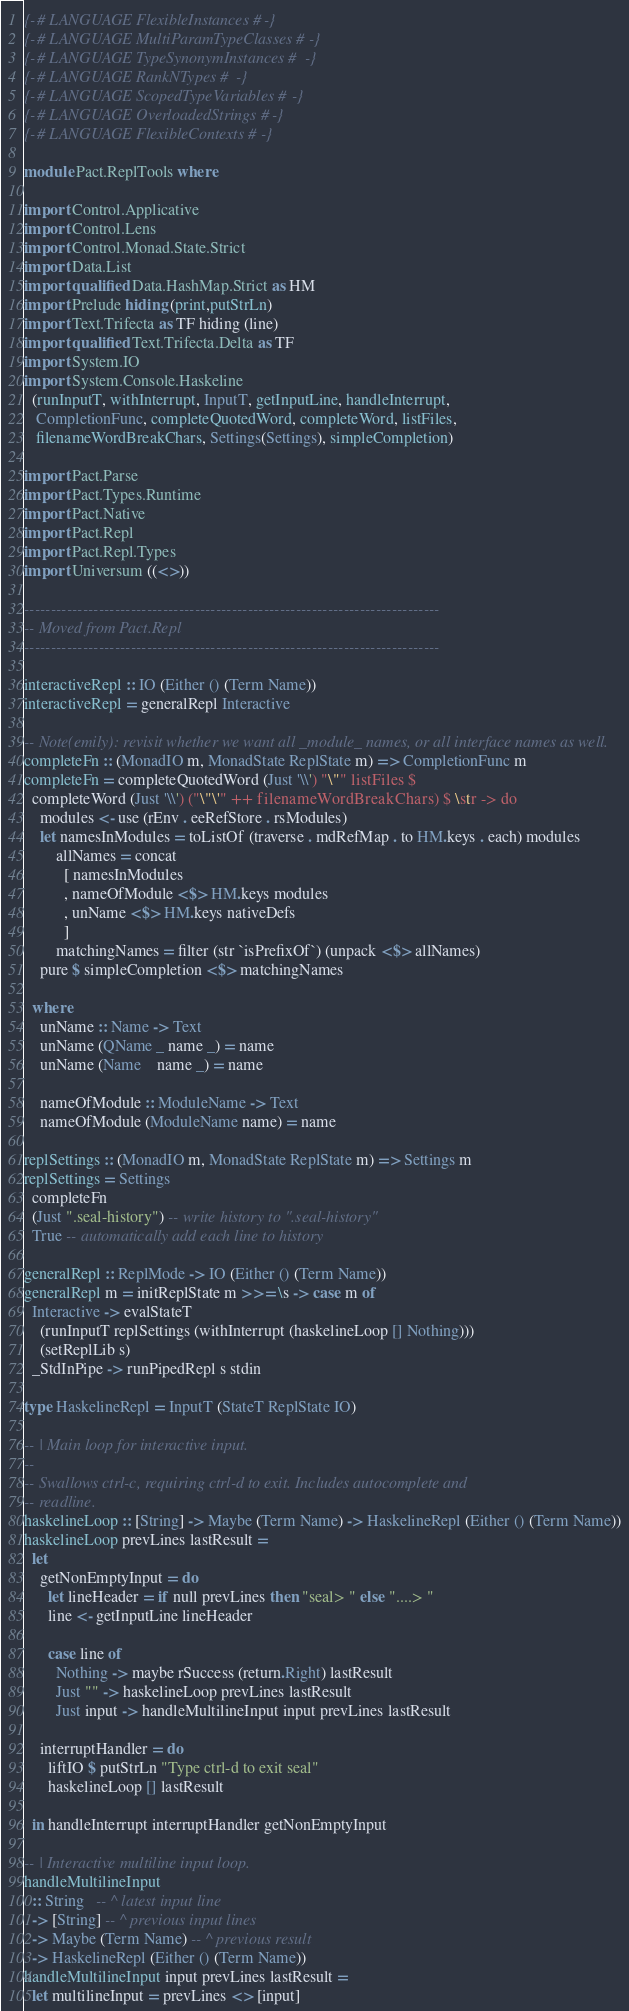Convert code to text. <code><loc_0><loc_0><loc_500><loc_500><_Haskell_>{-# LANGUAGE FlexibleInstances #-}
{-# LANGUAGE MultiParamTypeClasses #-}
{-# LANGUAGE TypeSynonymInstances #-}
{-# LANGUAGE RankNTypes #-}
{-# LANGUAGE ScopedTypeVariables #-}
{-# LANGUAGE OverloadedStrings #-}
{-# LANGUAGE FlexibleContexts #-}

module Pact.ReplTools where

import Control.Applicative
import Control.Lens
import Control.Monad.State.Strict
import Data.List
import qualified Data.HashMap.Strict as HM
import Prelude hiding (print,putStrLn)
import Text.Trifecta as TF hiding (line)
import qualified Text.Trifecta.Delta as TF
import System.IO
import System.Console.Haskeline
  (runInputT, withInterrupt, InputT, getInputLine, handleInterrupt,
   CompletionFunc, completeQuotedWord, completeWord, listFiles,
   filenameWordBreakChars, Settings(Settings), simpleCompletion)

import Pact.Parse
import Pact.Types.Runtime
import Pact.Native
import Pact.Repl
import Pact.Repl.Types
import Universum ((<>))

------------------------------------------------------------------------------
-- Moved from Pact.Repl
------------------------------------------------------------------------------

interactiveRepl :: IO (Either () (Term Name))
interactiveRepl = generalRepl Interactive

-- Note(emily): revisit whether we want all _module_ names, or all interface names as well.
completeFn :: (MonadIO m, MonadState ReplState m) => CompletionFunc m
completeFn = completeQuotedWord (Just '\\') "\"" listFiles $
  completeWord (Just '\\') ("\"\'" ++ filenameWordBreakChars) $ \str -> do
    modules <- use (rEnv . eeRefStore . rsModules)
    let namesInModules = toListOf (traverse . mdRefMap . to HM.keys . each) modules
        allNames = concat
          [ namesInModules
          , nameOfModule <$> HM.keys modules
          , unName <$> HM.keys nativeDefs
          ]
        matchingNames = filter (str `isPrefixOf`) (unpack <$> allNames)
    pure $ simpleCompletion <$> matchingNames

  where
    unName :: Name -> Text
    unName (QName _ name _) = name
    unName (Name    name _) = name

    nameOfModule :: ModuleName -> Text
    nameOfModule (ModuleName name) = name

replSettings :: (MonadIO m, MonadState ReplState m) => Settings m
replSettings = Settings
  completeFn
  (Just ".seal-history") -- write history to ".seal-history"
  True -- automatically add each line to history

generalRepl :: ReplMode -> IO (Either () (Term Name))
generalRepl m = initReplState m >>= \s -> case m of
  Interactive -> evalStateT
    (runInputT replSettings (withInterrupt (haskelineLoop [] Nothing)))
    (setReplLib s)
  _StdInPipe -> runPipedRepl s stdin

type HaskelineRepl = InputT (StateT ReplState IO)

-- | Main loop for interactive input.
--
-- Swallows ctrl-c, requiring ctrl-d to exit. Includes autocomplete and
-- readline.
haskelineLoop :: [String] -> Maybe (Term Name) -> HaskelineRepl (Either () (Term Name))
haskelineLoop prevLines lastResult =
  let
    getNonEmptyInput = do
      let lineHeader = if null prevLines then "seal> " else "....> "
      line <- getInputLine lineHeader

      case line of
        Nothing -> maybe rSuccess (return.Right) lastResult
        Just "" -> haskelineLoop prevLines lastResult
        Just input -> handleMultilineInput input prevLines lastResult

    interruptHandler = do
      liftIO $ putStrLn "Type ctrl-d to exit seal"
      haskelineLoop [] lastResult

  in handleInterrupt interruptHandler getNonEmptyInput

-- | Interactive multiline input loop.
handleMultilineInput
  :: String   -- ^ latest input line
  -> [String] -- ^ previous input lines
  -> Maybe (Term Name) -- ^ previous result
  -> HaskelineRepl (Either () (Term Name))
handleMultilineInput input prevLines lastResult =
  let multilineInput = prevLines <> [input]</code> 